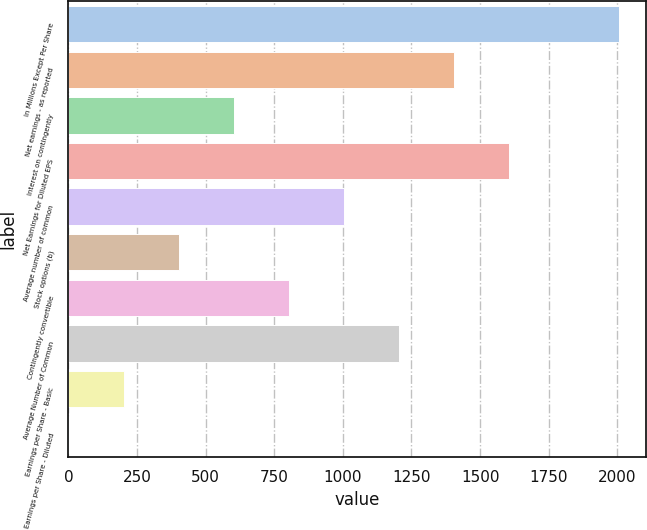Convert chart. <chart><loc_0><loc_0><loc_500><loc_500><bar_chart><fcel>In Millions Except Per Share<fcel>Net earnings - as reported<fcel>Interest on contingently<fcel>Net Earnings for Diluted EPS<fcel>Average number of common<fcel>Stock options (b)<fcel>Contingently convertible<fcel>Average Number of Common<fcel>Earnings per Share - Basic<fcel>Earnings per Share - Diluted<nl><fcel>2005<fcel>1404.41<fcel>603.65<fcel>1604.6<fcel>1004.03<fcel>403.46<fcel>803.84<fcel>1204.22<fcel>203.27<fcel>3.08<nl></chart> 